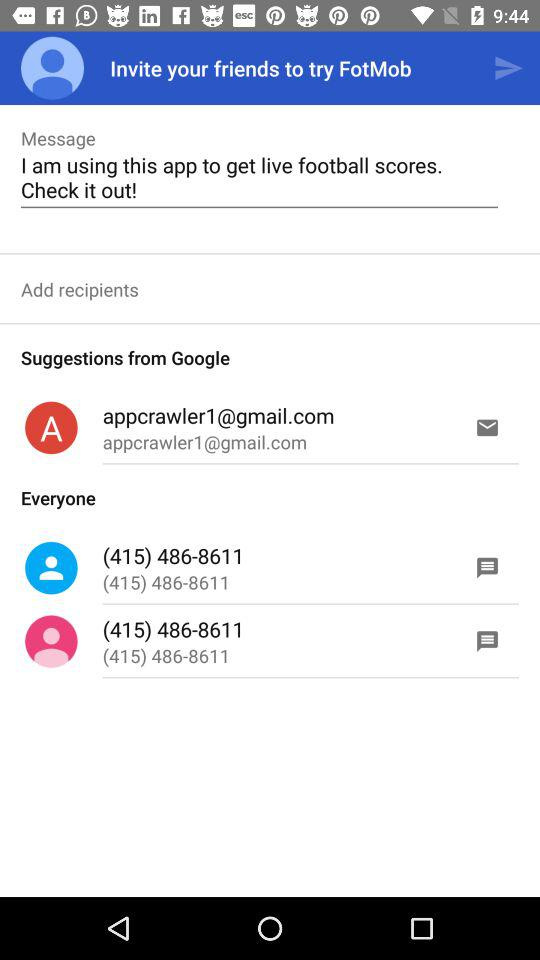What's the Google mail address used by the user for the application? The Google mail address used by the user for the application is appcrawler1@gmail.com. 